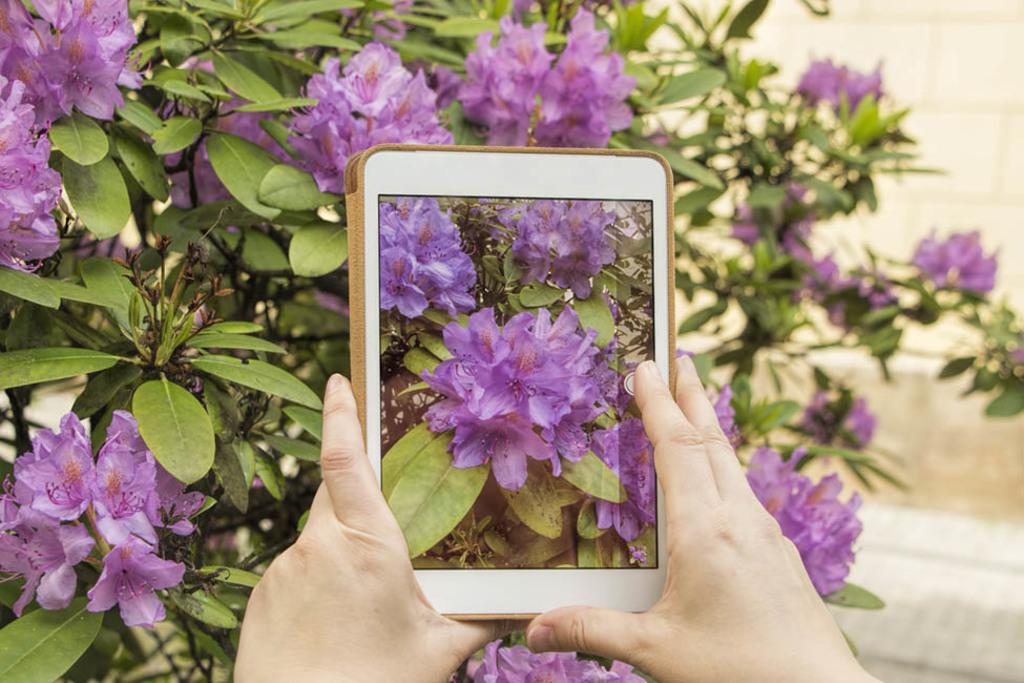What can be seen in the image that belongs to a person? There are hands of a person in the image. What is the person holding in the image? The person is holding a tab. What type of plant is visible in the image? There is a tree with flowers in the image. How would you describe the background of the image? The background is blurred. What level of fear can be observed in the person's face in the image? There is no face visible in the image, only the person's hands holding a tab. Is the alley visible in the image? There is no alley present in the image; it features a tree with flowers, and a blurred background. 